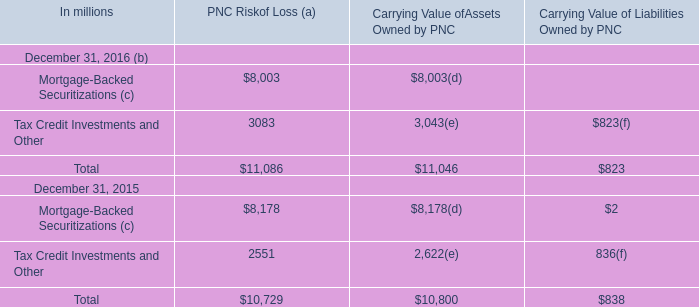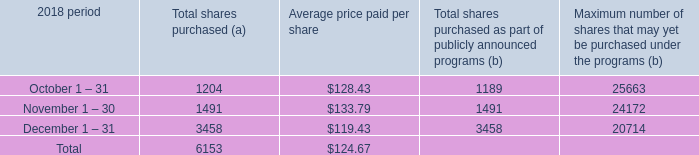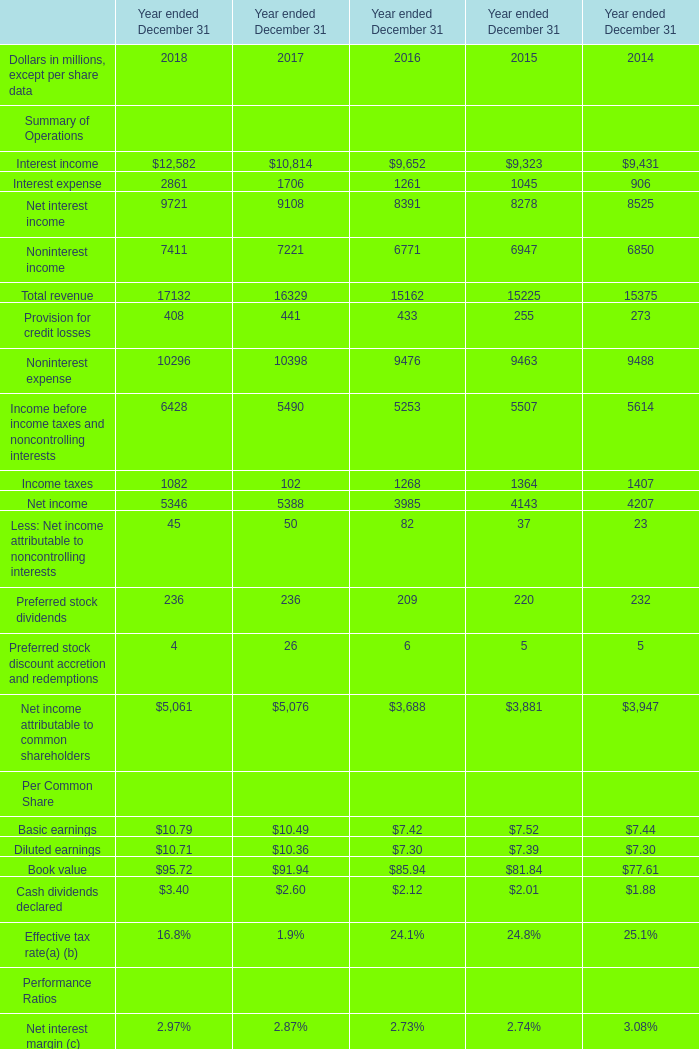What's the increasing rate of Total revenue in 2018 ended December 31? 
Computations: ((17132 - 16329) / 16329)
Answer: 0.04918. 